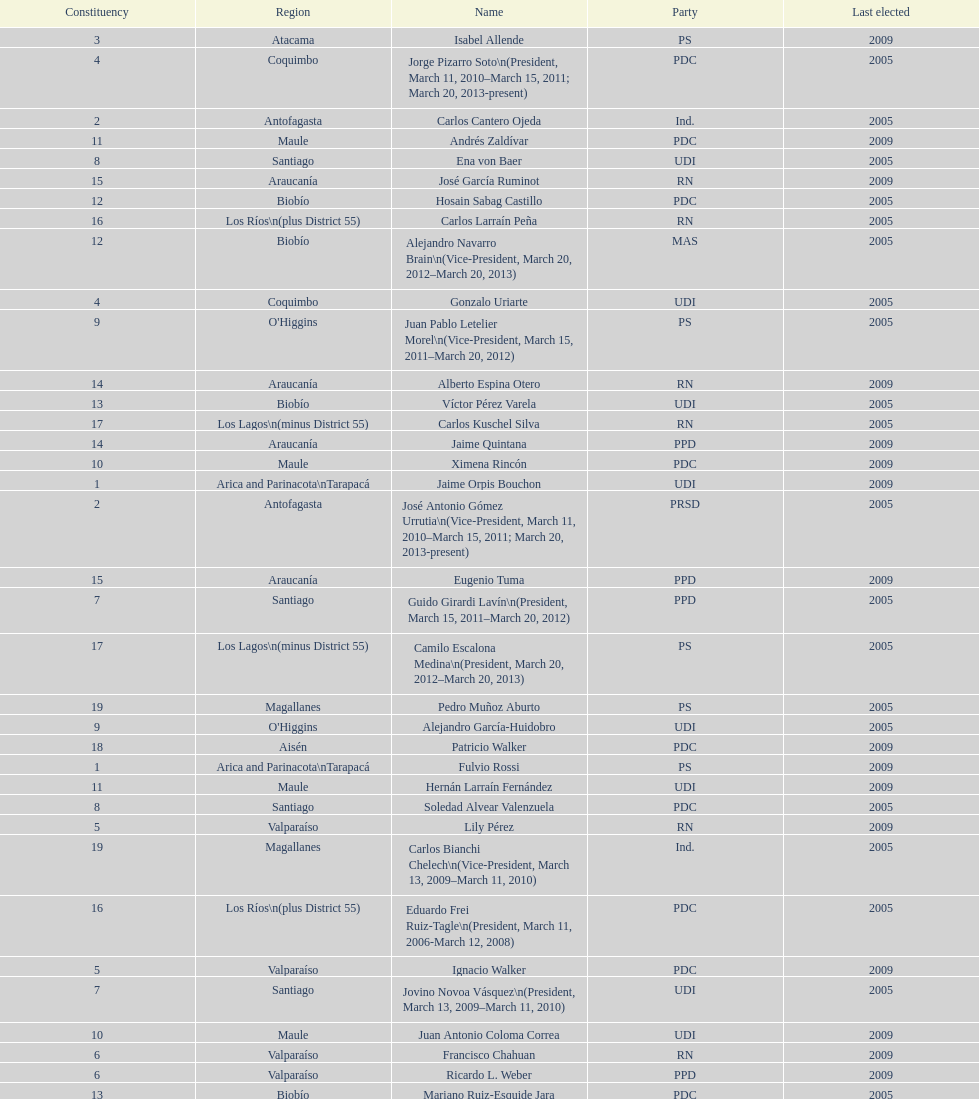Which region is listed below atacama? Coquimbo. 